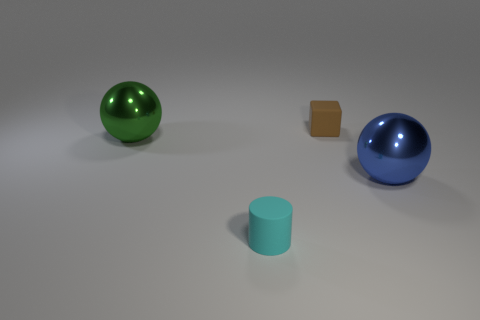Is the number of cylinders greater than the number of cyan rubber spheres?
Your response must be concise. Yes. What is the tiny block made of?
Provide a succinct answer. Rubber. Is the size of the object that is in front of the blue metal ball the same as the tiny cube?
Offer a very short reply. Yes. There is a metallic object on the left side of the tiny cyan matte object; how big is it?
Make the answer very short. Large. Are there any other things that have the same material as the green thing?
Give a very brief answer. Yes. How many green metal things are there?
Make the answer very short. 1. Do the matte cylinder and the cube have the same color?
Your response must be concise. No. What color is the object that is to the right of the small cyan object and in front of the tiny brown object?
Ensure brevity in your answer.  Blue. There is a big blue shiny thing; are there any big green shiny spheres on the right side of it?
Your answer should be very brief. No. There is a large shiny object right of the rubber block; how many metal balls are on the right side of it?
Your answer should be compact. 0. 